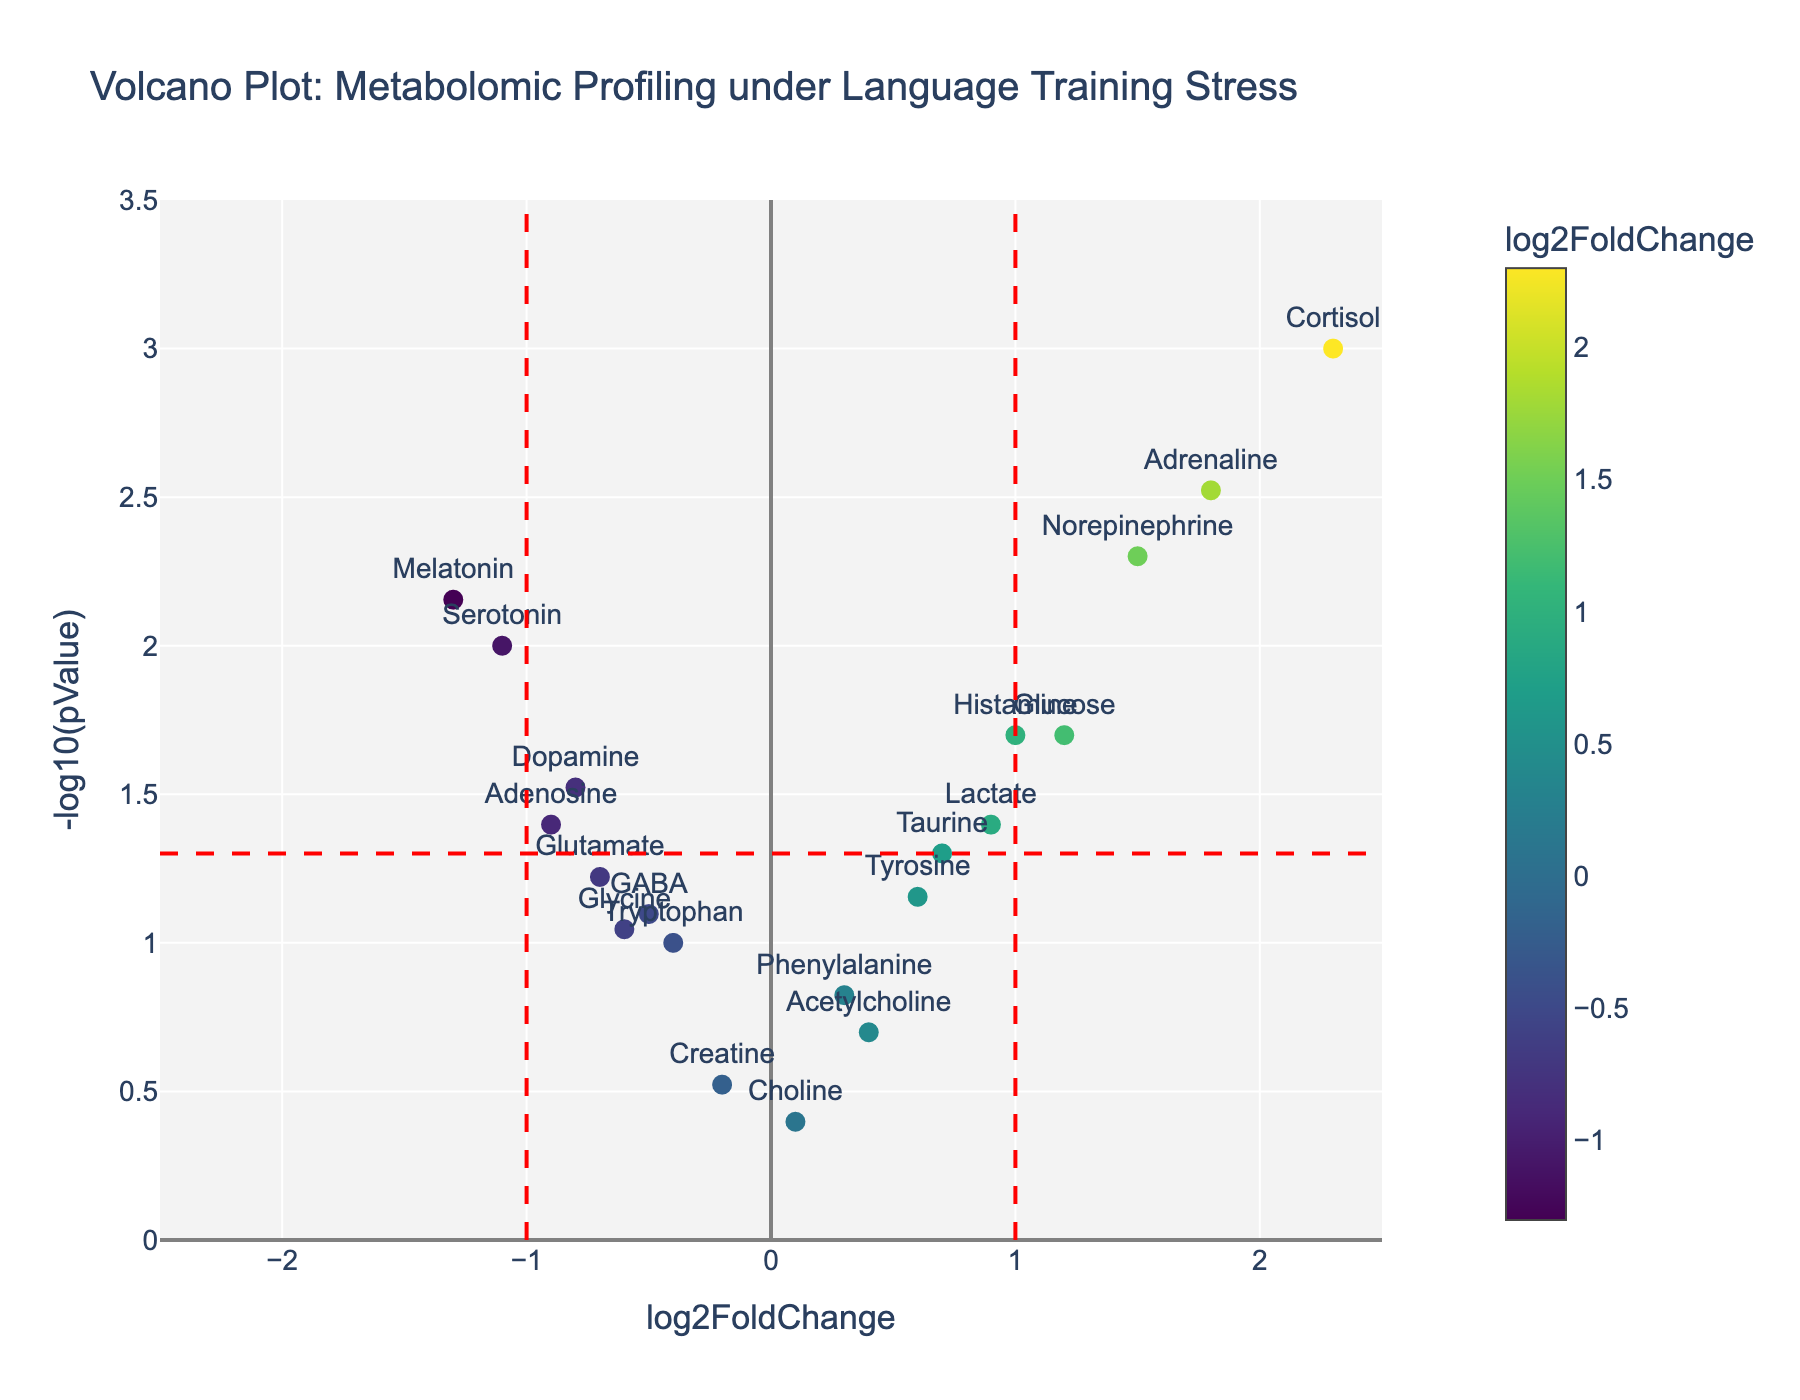What is the title of the plot? The title of the plot is prominently displayed at the top and typically summarizes the data being visualized. It reads "Volcano Plot: Metabolomic Profiling under Language Training Stress."
Answer: Volcano Plot: Metabolomic Profiling under Language Training Stress Which compound has the highest log2FoldChange value? To determine the compound with the highest log2FoldChange value, look at the x-axis and identify the data point furthest to the right. The compound labeled near this point is "Cortisol" which has a log2FoldChange value of 2.3.
Answer: Cortisol How many compounds have a pValue less than 0.05? To find the number of compounds with a pValue less than 0.05, look for data points above the horizontal dashed red line. Counting these points gives nine compounds.
Answer: 9 Which compound has the lowest -log10(pValue) among those with a negative log2FoldChange? First, focus on compounds with negative log2FoldChange (left side of the vertical line at x=0). Then, identify the compound with the smallest y-value among these points. "Tryptophan" has the lowest -log10(pValue) in this category.
Answer: Tryptophan Which compound has a log2FoldChange between 1 and 1.5? To find a compound with a log2FoldChange between 1 and 1.5, look at data points between these values along the x-axis. The compound "Histamine" falls within this range.
Answer: Histamine What is the -log10(pValue) of Serotonin? Locate the "Serotonin" data point on the plot and read its y-axis value. The -log10(pValue) for Serotonin is approximately 2.
Answer: 2 Which compound is more significant in terms of pValue, Norepinephrine or Dopamine? The significance in terms of pValue is represented by the height on the plot. Compare the y-values of the points labeled "Norepinephrine" and "Dopamine." Norepinephrine has a higher -log10(pValue), indicating a more significant pValue.
Answer: Norepinephrine How many compounds have a log2FoldChange greater than 1? Count the number of data points to the right of the vertical dashed red line at x=1. There are four compounds with a log2FoldChange greater than 1.
Answer: 4 What color represents the highest log2FoldChange? The plot uses a colorscale to represent log2FoldChange values. The brightest color, which appears yellow-green according to the Viridis scale, represents the highest log2FoldChange, i.e., 2.3 for "Cortisol."
Answer: Yellow-green 